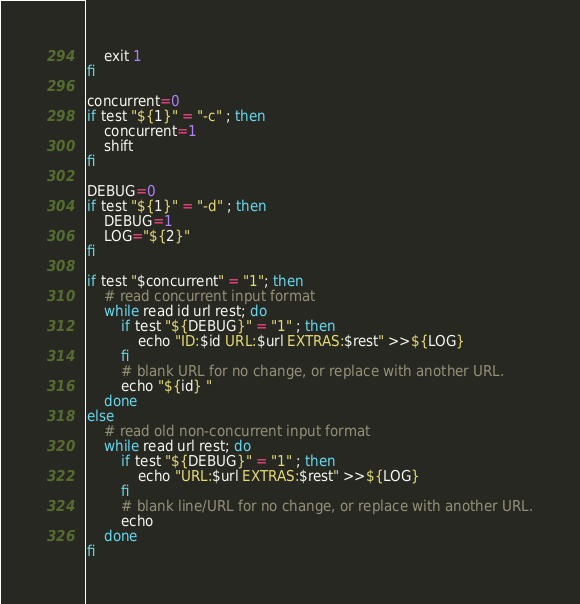Convert code to text. <code><loc_0><loc_0><loc_500><loc_500><_Bash_>	exit 1
fi

concurrent=0
if test "${1}" = "-c" ; then
	concurrent=1
	shift
fi

DEBUG=0
if test "${1}" = "-d" ; then
	DEBUG=1
	LOG="${2}"
fi

if test "$concurrent" = "1"; then
	# read concurrent input format
	while read id url rest; do
		if test "${DEBUG}" = "1" ; then
			echo "ID:$id URL:$url EXTRAS:$rest" >>${LOG}
		fi
		# blank URL for no change, or replace with another URL.
		echo "${id} "
	done
else
	# read old non-concurrent input format
	while read url rest; do
		if test "${DEBUG}" = "1" ; then
			echo "URL:$url EXTRAS:$rest" >>${LOG}
		fi
		# blank line/URL for no change, or replace with another URL.
		echo
	done
fi
</code> 